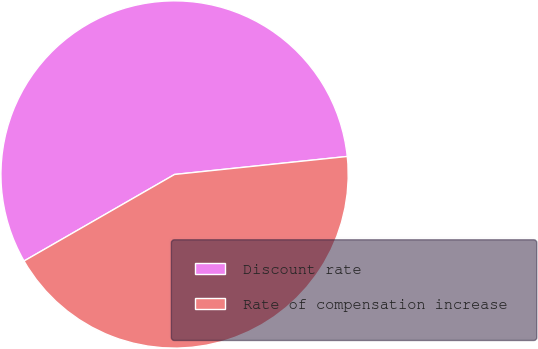<chart> <loc_0><loc_0><loc_500><loc_500><pie_chart><fcel>Discount rate<fcel>Rate of compensation increase<nl><fcel>56.65%<fcel>43.35%<nl></chart> 